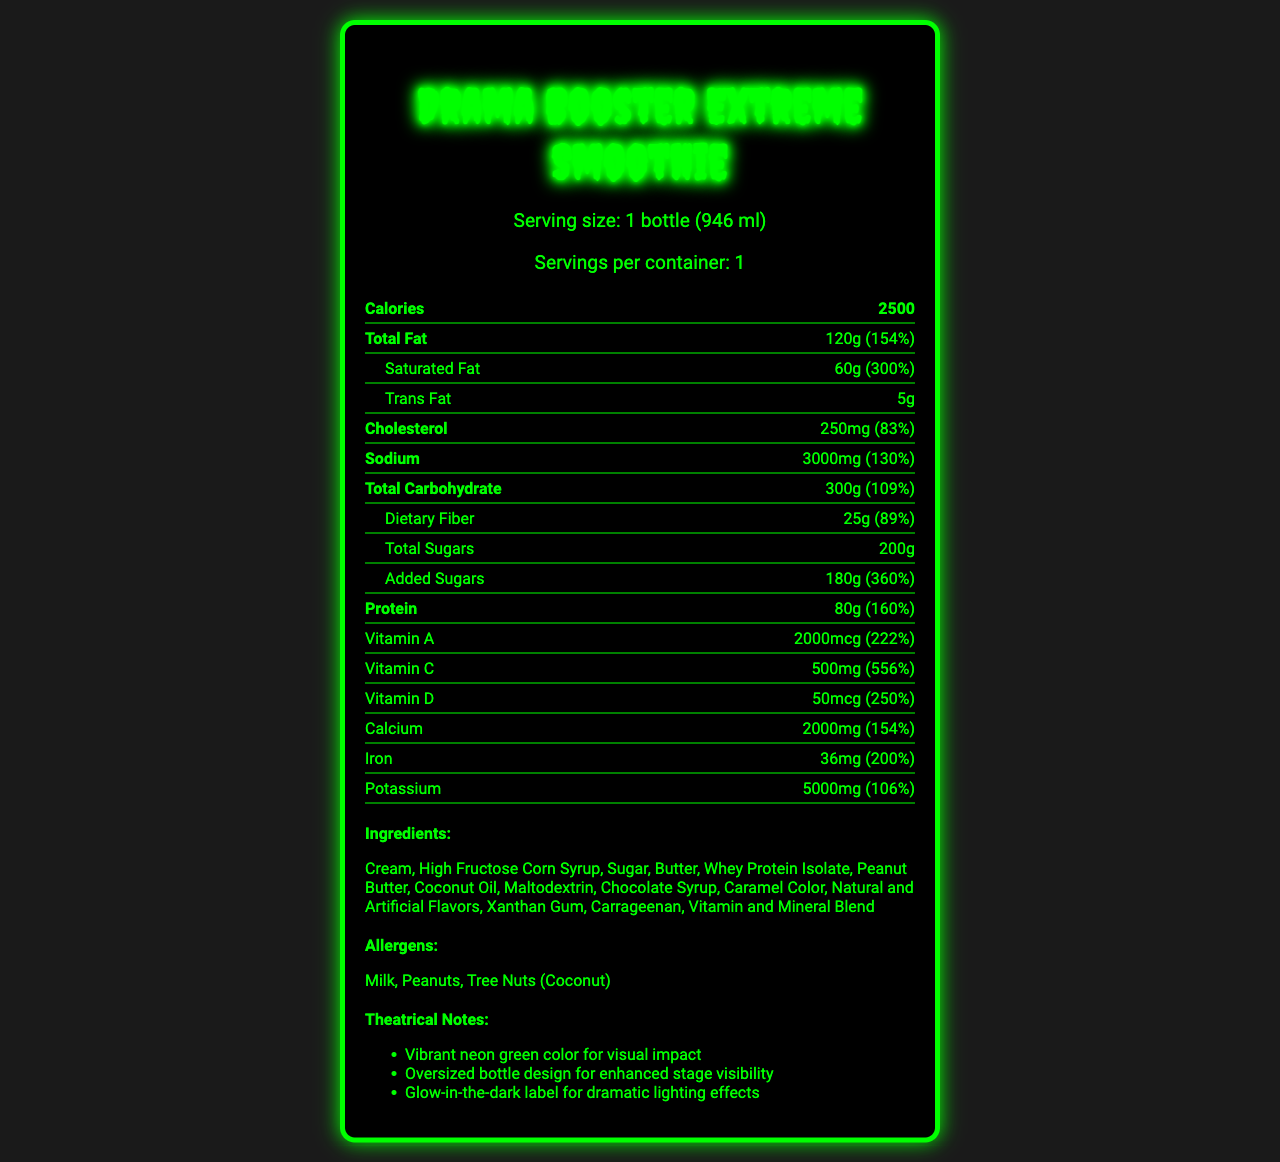what is the serving size of the Drama Booster Extreme Smoothie? The serving size is explicitly mentioned in the serving information section under the product name.
Answer: 1 bottle (946 ml) how many calories are in one serving of the Drama Booster Extreme Smoothie? The number of calories per serving is listed right under the serving information section.
Answer: 2500 what is the total amount of fat in the smoothie, and what percentage of the daily value does that represent? The total fat amount and its corresponding daily value percentage are provided in the nutrient rows under the section for fat.
Answer: 120g, 154% how much saturated fat is in the smoothie? The amount of saturated fat and its daily value percentage is detailed right below the total fat information.
Answer: 60g (300% DV) what are the three main allergenic ingredients in the Drama Booster Extreme Smoothie? The allergens section lists these three ingredients explicitly.
Answer: Milk, Peanuts, Tree Nuts (Coconut) what is the amount of sodium in the smoothie? A. 1000mg B. 2000mg C. 3000mg D. 4000mg The nutrient row for sodium lists it as 3000mg.
Answer: C how much protein does the Drama Booster Extreme Smoothie contain? A. 50g B. 60g C. 70g D. 80g The nutrient row for protein lists it as 80g.
Answer: D is the label designed to be visually impactful on stage? The theatrical notes section mentions attributes like vibrant neon green color and glow-in-the-dark label, indicating a focus on visual impact for the stage.
Answer: Yes does the total carbohydrate amount exceed 300g? The total carbohydrate amount is exactly 300g as mentioned in the nutrients section.
Answer: No summarize the main idea of the Drama Booster Extreme Smoothie nutrition facts label. The document provides a comprehensive breakdown of all nutritional elements, ingredients, and stage-related design notes emphasizing the high-calorie nature and dramatic visual effects.
Answer: The label describes the nutritional content of a highly exaggerated smoothie with high calorie and fat content, detailed per-serving nutritional values, key ingredients, allergens, and theatrical design features. what is the exact amount of high fructose corn syrup in the smoothie? The document lists high fructose corn syrup as an ingredient, but does not specify the exact amount used.
Answer: Cannot be determined 